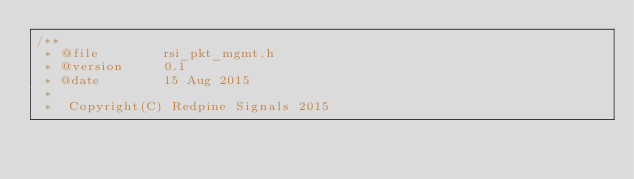<code> <loc_0><loc_0><loc_500><loc_500><_C_>/**
 * @file        rsi_pkt_mgmt.h
 * @version     0.1
 * @date        15 Aug 2015
 *
 *  Copyright(C) Redpine Signals 2015</code> 